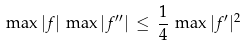<formula> <loc_0><loc_0><loc_500><loc_500>\max | f | \, \max | f ^ { \prime \prime } | \, \leq \, \frac { 1 } { 4 } \, \max | f ^ { \prime } | ^ { 2 }</formula> 